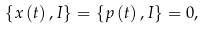Convert formula to latex. <formula><loc_0><loc_0><loc_500><loc_500>\left \{ x \left ( t \right ) , I \right \} = \left \{ p \left ( t \right ) , I \right \} = 0 ,</formula> 